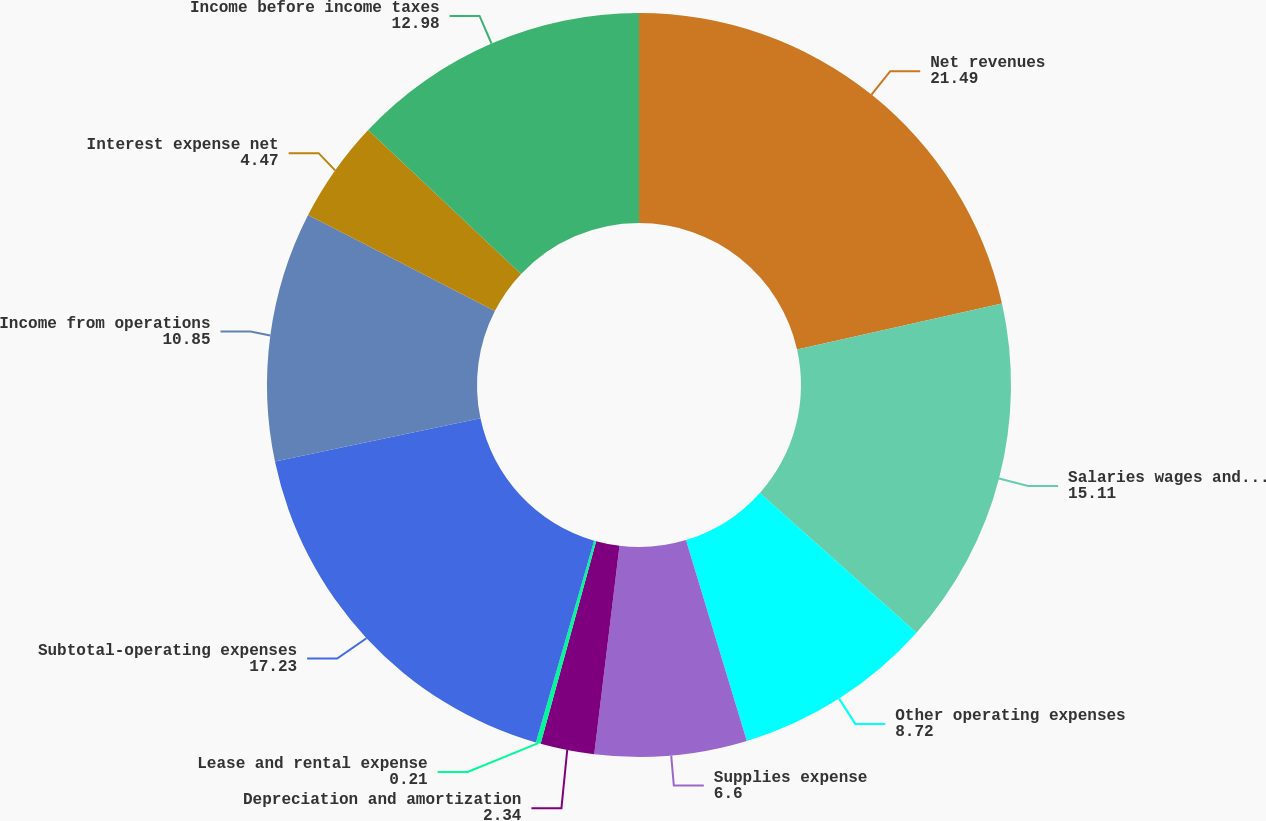Convert chart to OTSL. <chart><loc_0><loc_0><loc_500><loc_500><pie_chart><fcel>Net revenues<fcel>Salaries wages and benefits<fcel>Other operating expenses<fcel>Supplies expense<fcel>Depreciation and amortization<fcel>Lease and rental expense<fcel>Subtotal-operating expenses<fcel>Income from operations<fcel>Interest expense net<fcel>Income before income taxes<nl><fcel>21.49%<fcel>15.11%<fcel>8.72%<fcel>6.6%<fcel>2.34%<fcel>0.21%<fcel>17.23%<fcel>10.85%<fcel>4.47%<fcel>12.98%<nl></chart> 